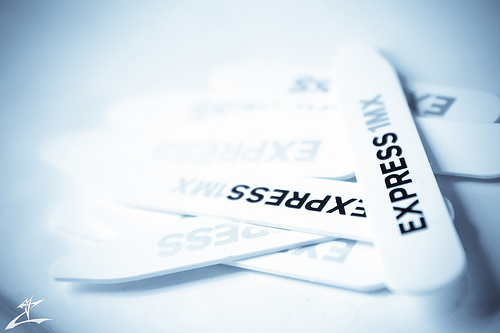<image>
Is there a stick thingy on the stick thingy? Yes. Looking at the image, I can see the stick thingy is positioned on top of the stick thingy, with the stick thingy providing support. 